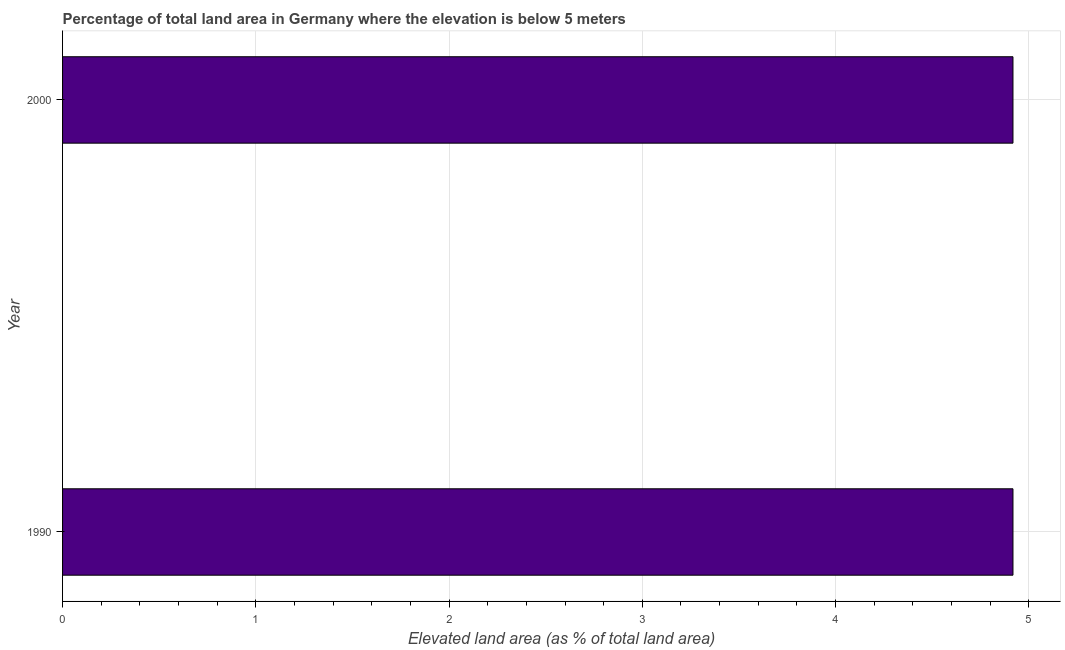Does the graph contain any zero values?
Ensure brevity in your answer.  No. Does the graph contain grids?
Your response must be concise. Yes. What is the title of the graph?
Keep it short and to the point. Percentage of total land area in Germany where the elevation is below 5 meters. What is the label or title of the X-axis?
Make the answer very short. Elevated land area (as % of total land area). What is the total elevated land area in 1990?
Offer a terse response. 4.92. Across all years, what is the maximum total elevated land area?
Ensure brevity in your answer.  4.92. Across all years, what is the minimum total elevated land area?
Keep it short and to the point. 4.92. What is the sum of the total elevated land area?
Provide a short and direct response. 9.84. What is the difference between the total elevated land area in 1990 and 2000?
Your response must be concise. 0. What is the average total elevated land area per year?
Your response must be concise. 4.92. What is the median total elevated land area?
Offer a very short reply. 4.92. In how many years, is the total elevated land area greater than 2.6 %?
Your answer should be compact. 2. Do a majority of the years between 1990 and 2000 (inclusive) have total elevated land area greater than 4.2 %?
Offer a very short reply. Yes. What is the ratio of the total elevated land area in 1990 to that in 2000?
Provide a short and direct response. 1. Is the total elevated land area in 1990 less than that in 2000?
Offer a terse response. No. In how many years, is the total elevated land area greater than the average total elevated land area taken over all years?
Provide a succinct answer. 0. How many bars are there?
Your response must be concise. 2. Are all the bars in the graph horizontal?
Your answer should be compact. Yes. What is the Elevated land area (as % of total land area) of 1990?
Your answer should be compact. 4.92. What is the Elevated land area (as % of total land area) of 2000?
Provide a succinct answer. 4.92. What is the difference between the Elevated land area (as % of total land area) in 1990 and 2000?
Offer a very short reply. 0. What is the ratio of the Elevated land area (as % of total land area) in 1990 to that in 2000?
Ensure brevity in your answer.  1. 